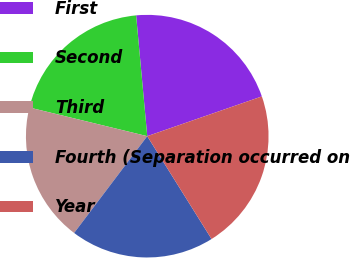Convert chart. <chart><loc_0><loc_0><loc_500><loc_500><pie_chart><fcel>First<fcel>Second<fcel>Third<fcel>Fourth (Separation occurred on<fcel>Year<nl><fcel>21.15%<fcel>19.74%<fcel>18.5%<fcel>19.19%<fcel>21.42%<nl></chart> 